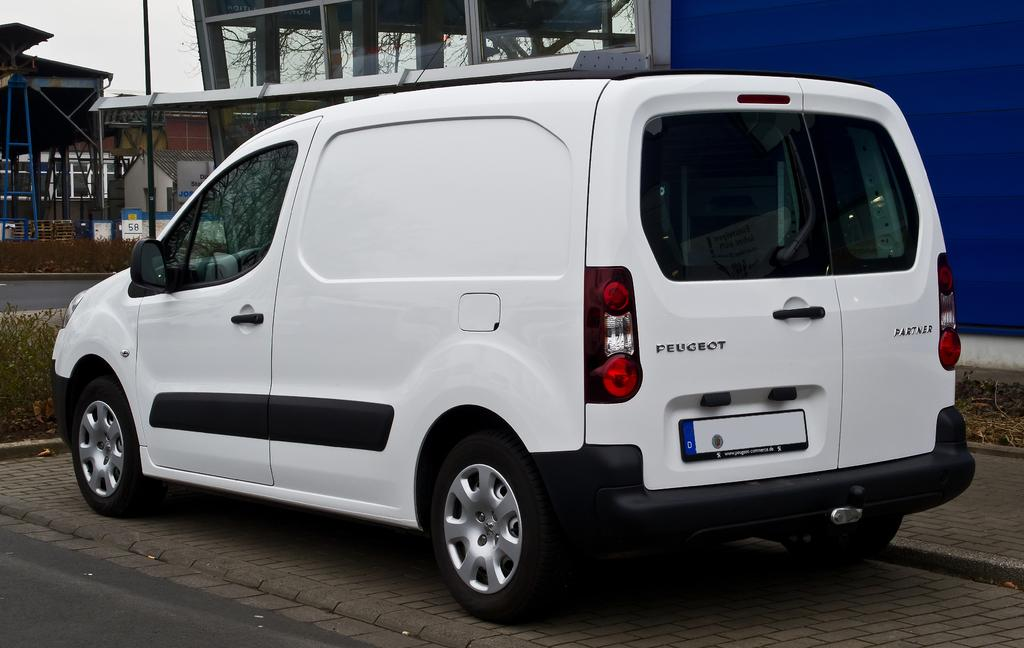What is the main subject of the image? There is a car in the image. Where is the car located in relation to the road? The car is near the roadside. What type of natural elements can be seen in the image? There are plants, branches, and the sky visible in the image. What man-made structures are present in the image? There are poles, boards, and buildings in the image. What verse is being recited by the car in the image? There is no indication that the car is reciting a verse or any form of speech in the image. How does the car's stomach feel after driving for a long time? Cars do not have stomachs, as they are inanimate objects, so this question cannot be answered. 